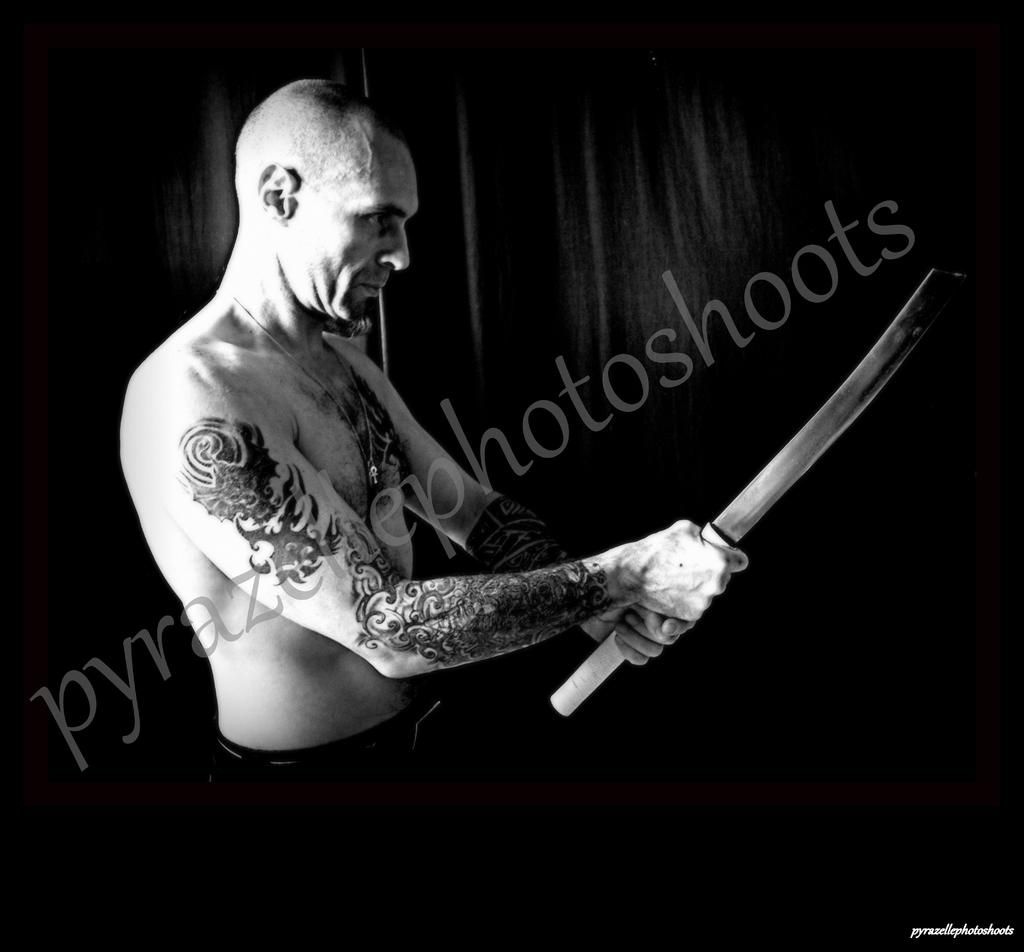What is the color scheme of the image? The image is black and white. Can you describe the person in the image? There is a man in the image. What is the man holding in his hands? The man is holding a weapon in his hands. How many pans can be seen in the image? There are no pans present in the image. Who is the father of the man in the image? There is no information about the man's father in the image. 